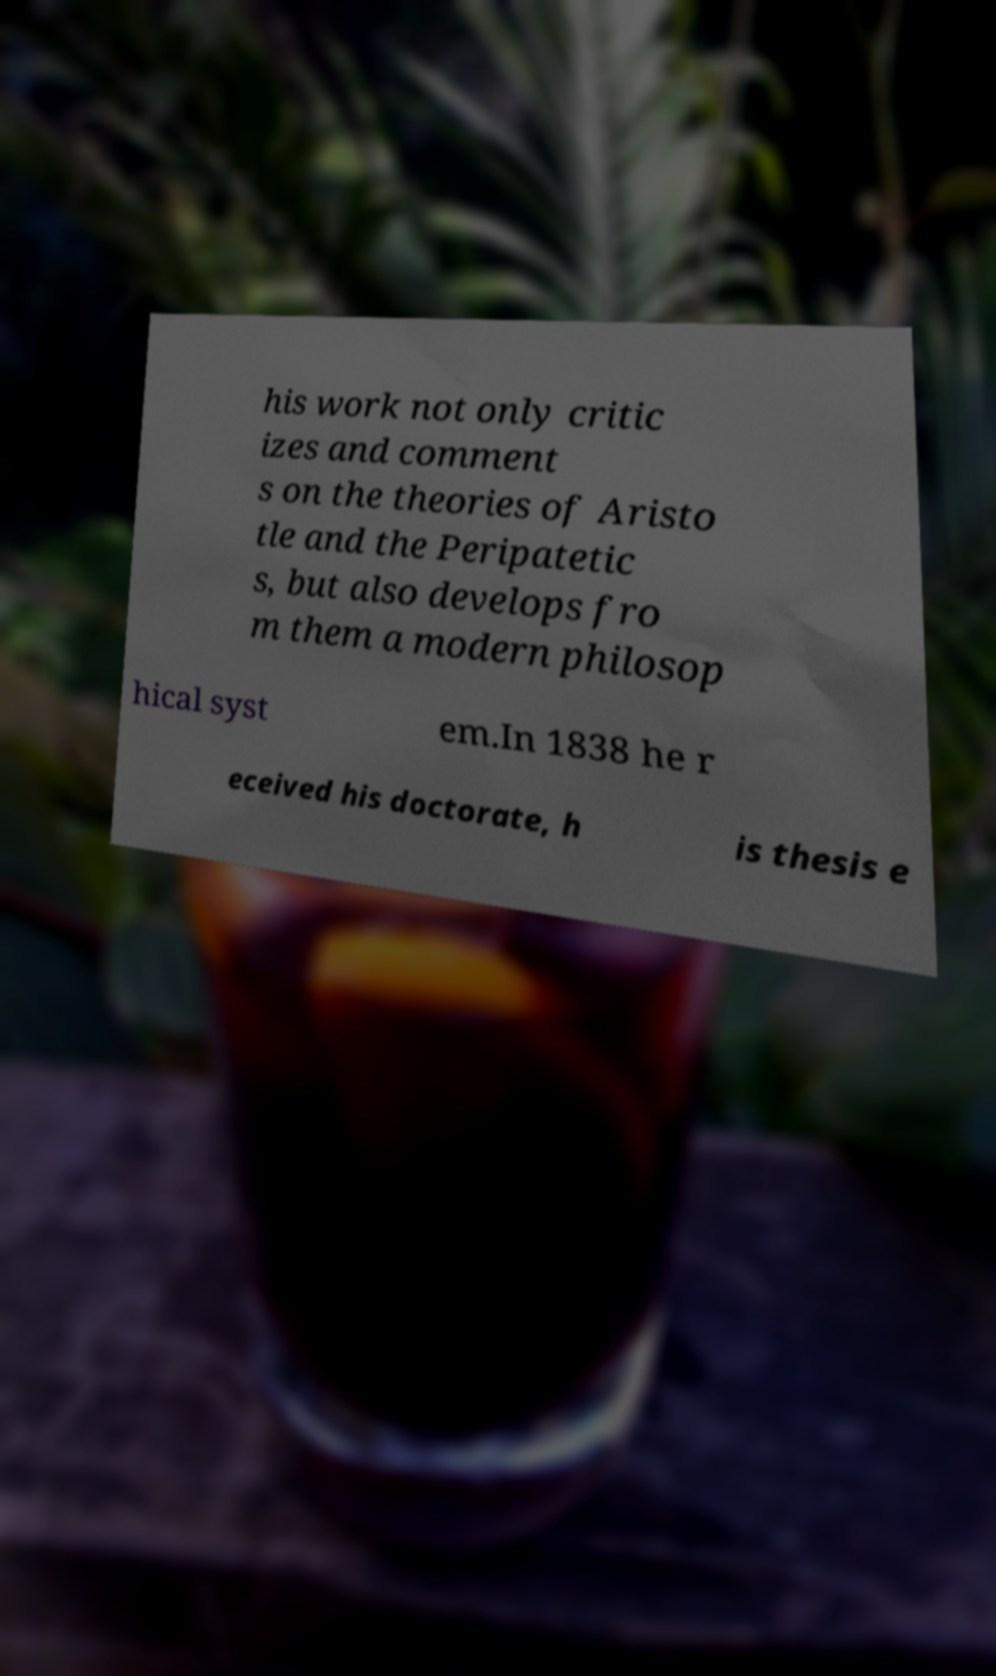Could you extract and type out the text from this image? his work not only critic izes and comment s on the theories of Aristo tle and the Peripatetic s, but also develops fro m them a modern philosop hical syst em.In 1838 he r eceived his doctorate, h is thesis e 